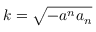Convert formula to latex. <formula><loc_0><loc_0><loc_500><loc_500>k = \sqrt { - a ^ { n } a _ { n } }</formula> 